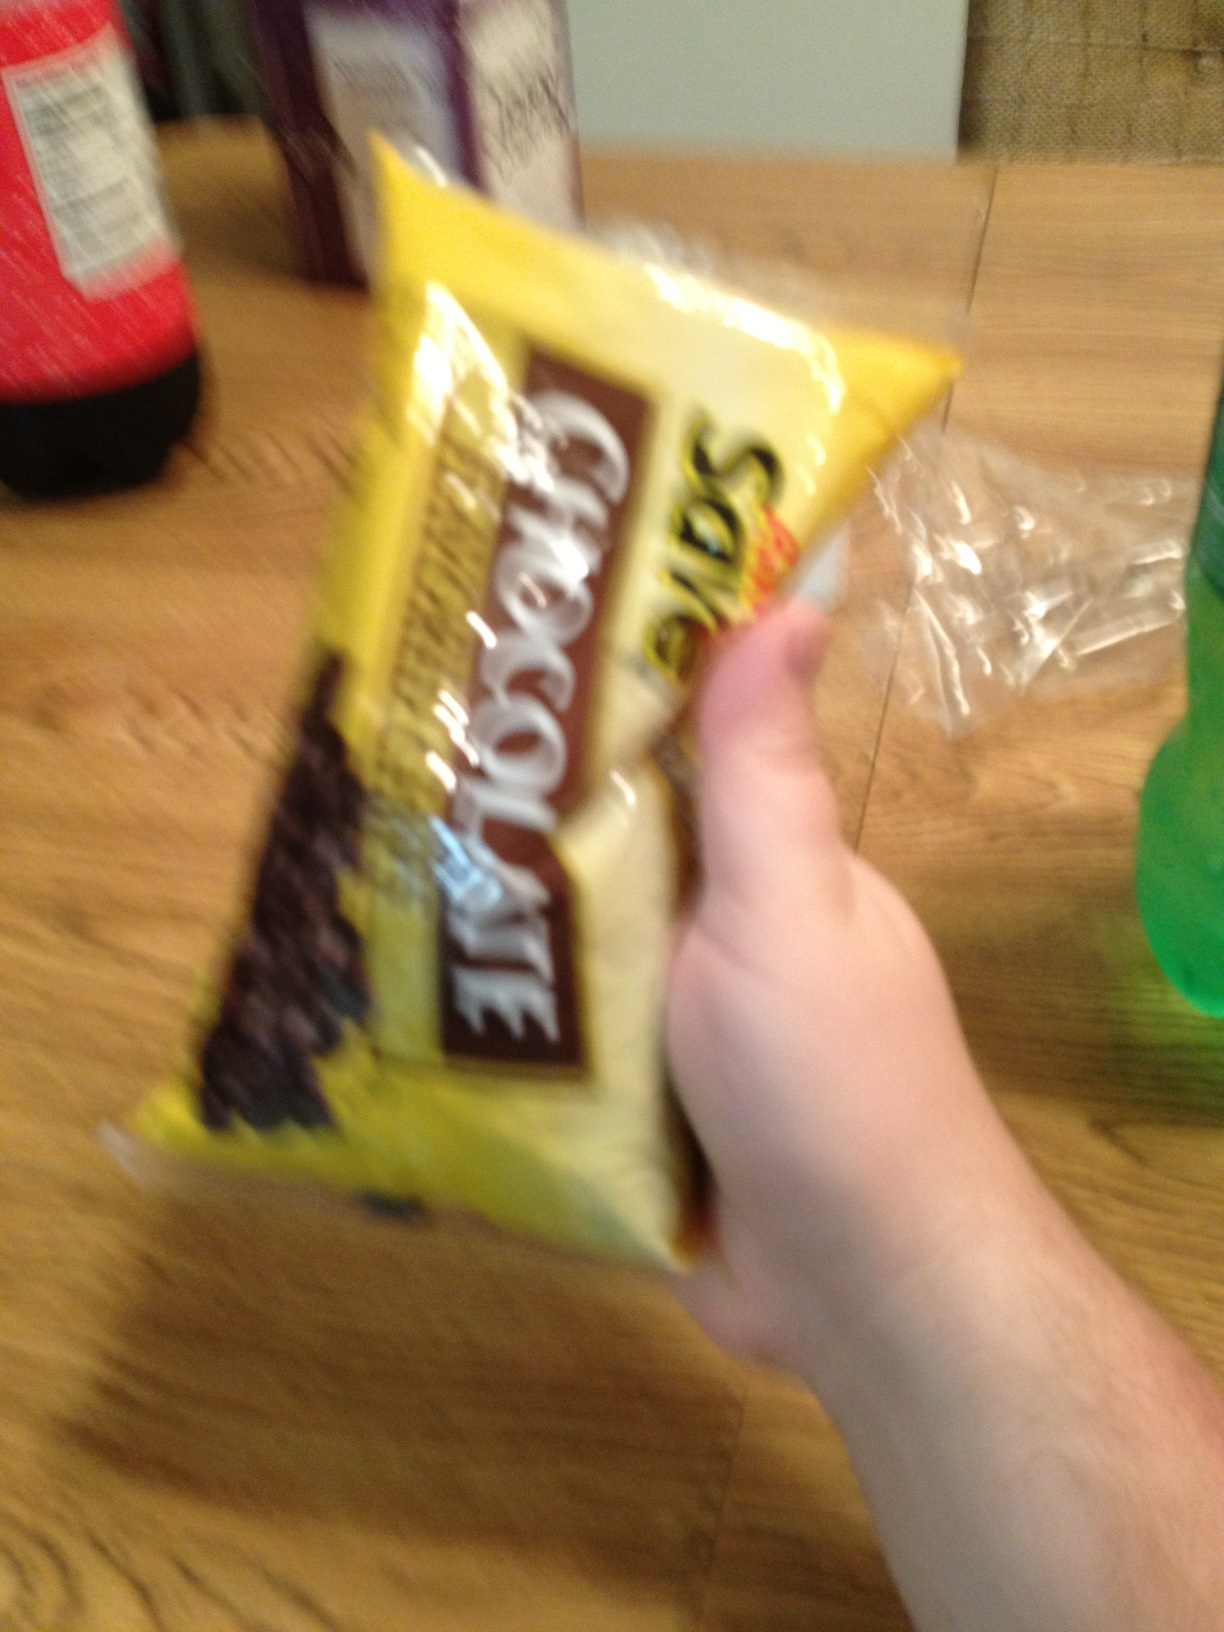How should chocolate chips be stored to maintain their quality? Chocolate chips should be stored in a cool, dry place, away from direct sunlight. An airtight container is recommended to keep them fresh and to prevent them from absorbing odors from other foods. 